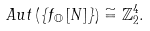Convert formula to latex. <formula><loc_0><loc_0><loc_500><loc_500>A u t \left ( \left \{ f _ { \mathbb { O } } \left [ N \right ] \right \} \right ) & \cong \mathbb { Z } _ { 2 } ^ { 4 } .</formula> 